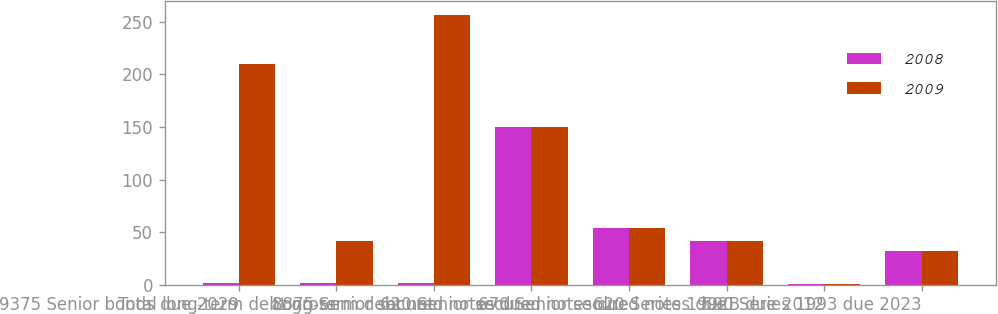<chart> <loc_0><loc_0><loc_500><loc_500><stacked_bar_chart><ecel><fcel>9375 Senior bonds due 2029<fcel>Total long-term debt gross<fcel>Long-term debt net<fcel>8875 Senior secured notes due<fcel>620 Senior secured notes due<fcel>670 Senior secured notes due<fcel>620 Series 1992B due 2012<fcel>590 Series 1993 due 2023<nl><fcel>2008<fcel>2<fcel>2<fcel>2<fcel>150<fcel>54<fcel>42<fcel>1<fcel>32<nl><fcel>2009<fcel>210<fcel>42<fcel>257<fcel>150<fcel>54<fcel>42<fcel>1<fcel>32<nl></chart> 